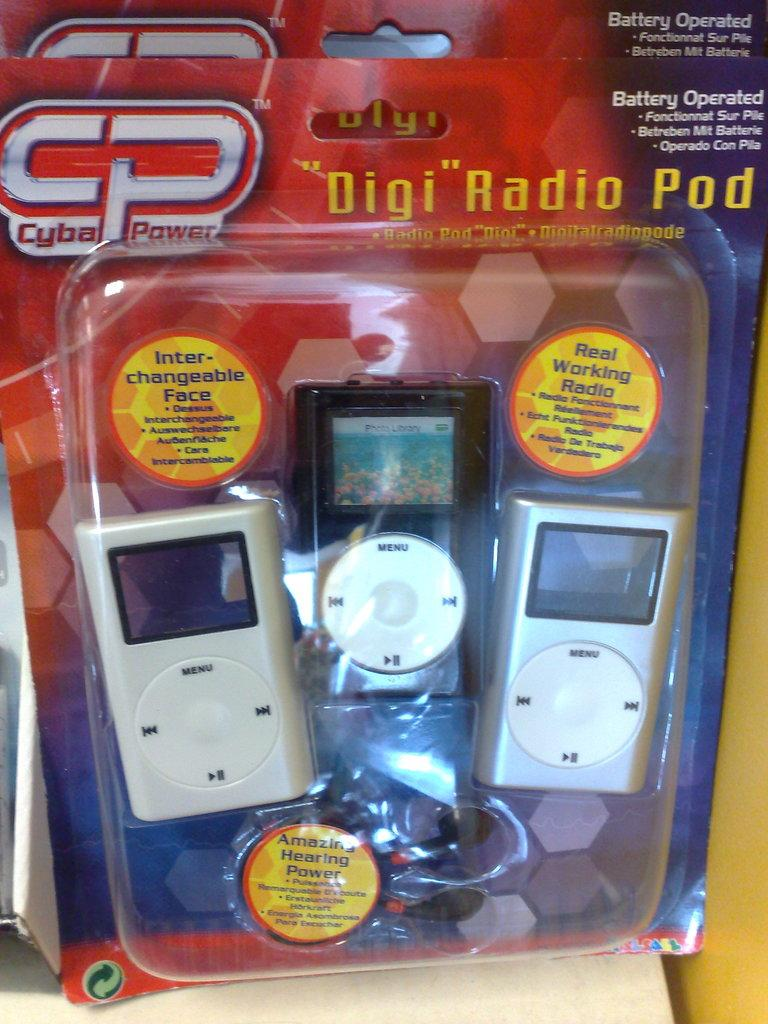What type of objects are present in the image? There are gadgets in the image. Can you hear the music coming from the gadgets in the image? There is no mention of music or any sound-related features in the image, so it cannot be determined from the image alone. 